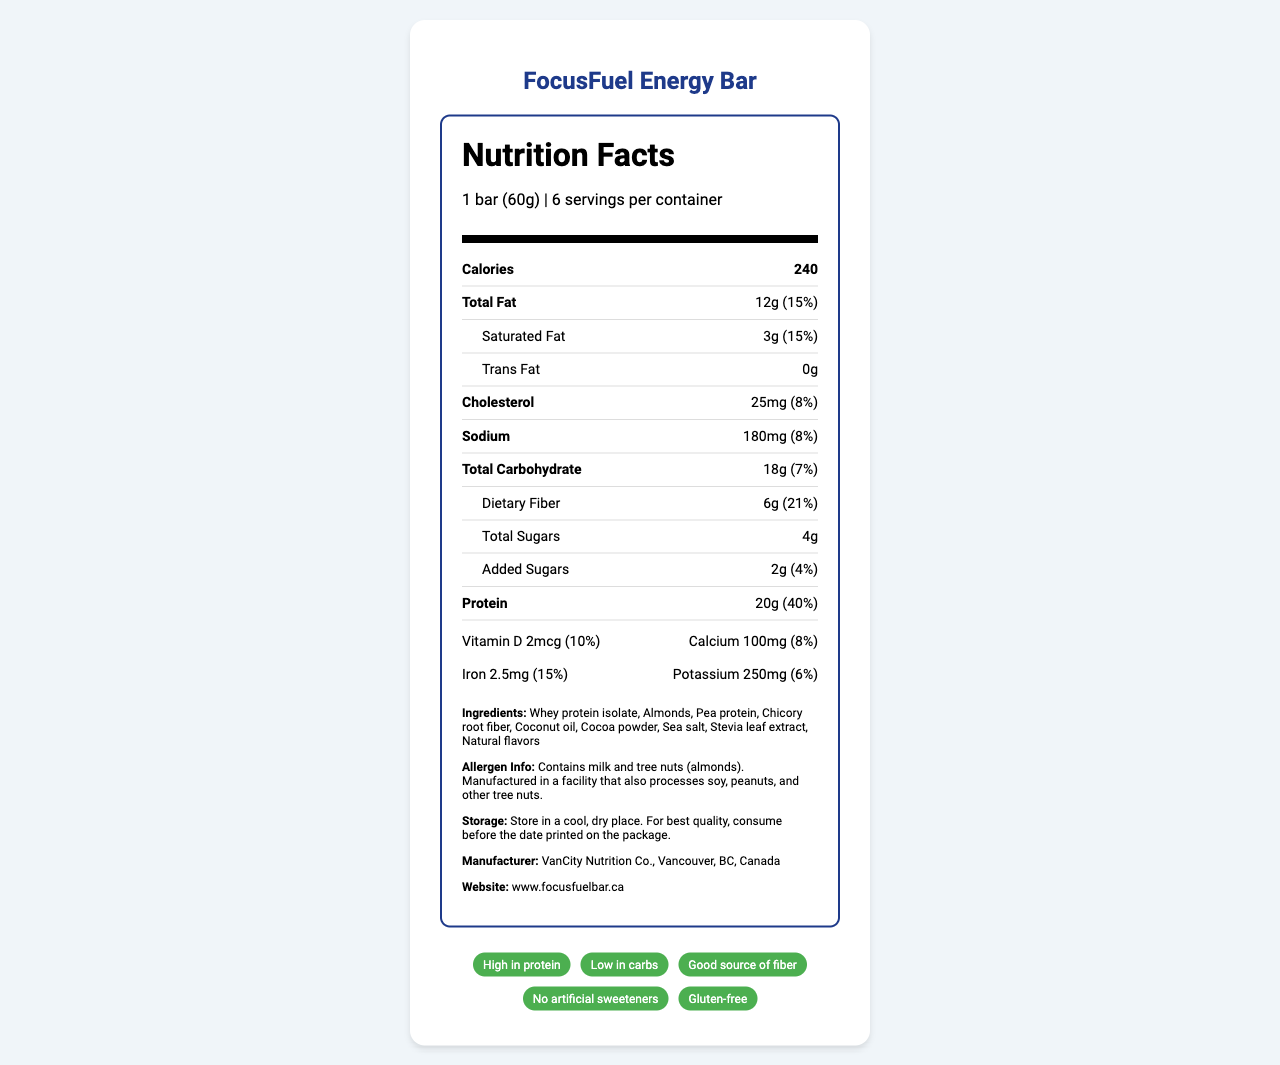what is the serving size of the FocusFuel Energy Bar? The serving size is explicitly stated at the beginning of the Nutrition Facts section.
Answer: 1 bar (60g) how many calories are in one serving of the FocusFuel Energy Bar? The number of calories per serving is listed prominently under the Nutrition Facts header.
Answer: 240 how much protein is in one serving of the FocusFuel Energy Bar? The amount of protein is specified in the Nutrition Facts section.
Answer: 20g what is the total amount of carbohydrates in one serving of the FocusFuel Energy Bar? The total carbohydrates are listed in the Nutrition Facts section.
Answer: 18g which allergen is NOT contained in the FocusFuel Energy Bar? A. Almonds B. Soy C. Peanuts The allergen info specifies that the bar contains milk and tree nuts (almonds) but not peanuts.
Answer: C how many servings are there per container of FocusFuel Energy Bar? The number of servings per container is listed at the beginning of the Nutrition Facts section.
Answer: 6 which ingredient is listed first in the FocusFuel Energy Bar? A. Almonds B. Whey protein isolate C. Chicory root fiber D. Stevia leaf extract Ingredients are listed in order of predominance, and Whey protein isolate is listed first.
Answer: B does the FocusFuel Energy Bar contain any trans fat? The Nutrition Facts section shows 0g of trans fat.
Answer: No what is the daily value percentage for dietary fiber in a FocusFuel Energy Bar? The daily value percentage for dietary fiber is specified in the Nutrition Facts section.
Answer: 21% which claim is NOT made about the FocusFuel Energy Bar? A. High in protein B. Low in carbs C. Contains artificial sweeteners D. Gluten-free The claims list states "No artificial sweeteners," implying it does not contain any.
Answer: C where is the FocusFuel Energy Bar manufactured? The manufacturing location is listed under the manufacturer information at the bottom of the document.
Answer: VanCity Nutrition Co., Vancouver, BC, Canada what is the main idea of the document? The document is a comprehensive label that includes nutritional details, ingredients, allergen info, and manufacturer details.
Answer: The Nutrition Facts Label provides detailed nutritional information for FocusFuel Energy Bar, highlighting its high protein, low-carb content, allergen information, ingredient list, storage instructions, and various marketing claims. what is the country of origin for the stevia leaf extract in the FocusFuel Energy Bar? The document does not provide specific information about the country of origin for individual ingredients like the stevia leaf extract.
Answer: Cannot be determined 